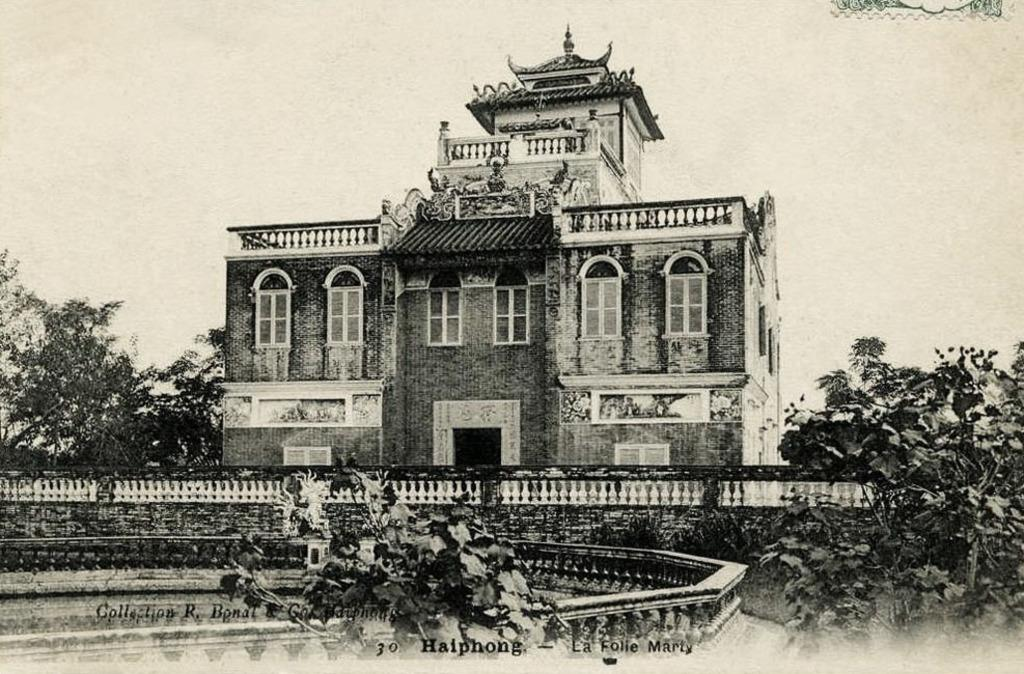What type of structure is visible in the image? There is a building in the image. What feature can be seen on the building? The building has windows. What type of vegetation is present in the image? There are trees and plants in the image. Can you describe the text at the bottom of the image? The text is written in black letters at the bottom portion of the image. What type of club is being used by the trees in the image? There are no clubs present in the image, and the trees are not using any objects. What is the yoke used for in the image? There is no yoke present in the image, so it cannot be used for anything. 